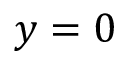Convert formula to latex. <formula><loc_0><loc_0><loc_500><loc_500>y = 0</formula> 